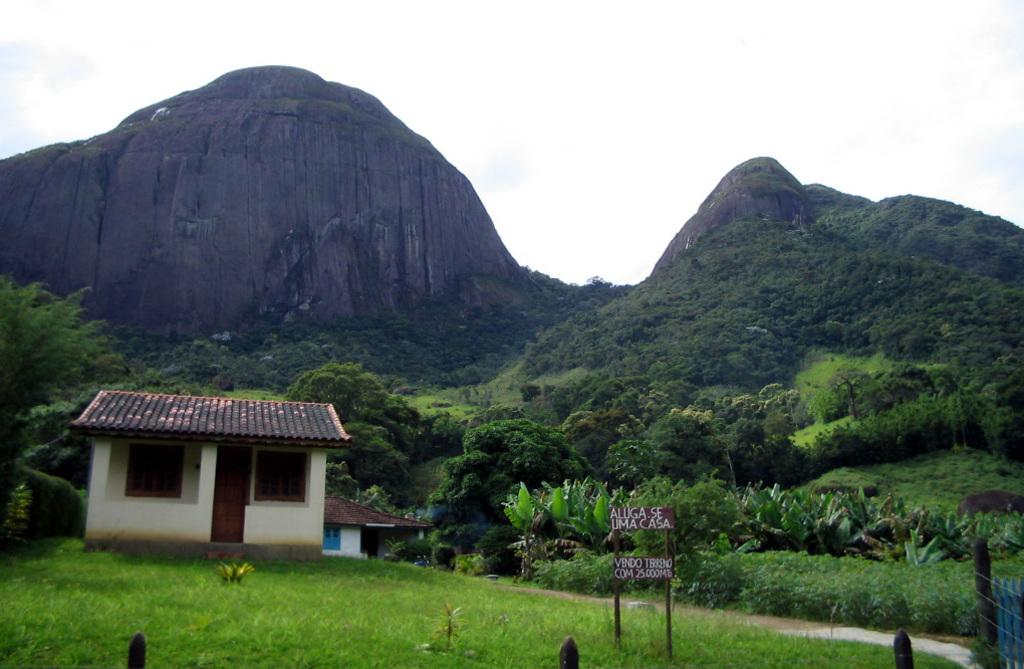What type of surface is in front of the image? There is grass on the surface in front of the image. What type of structures can be seen in the image? There are houses in the image. What are the name boards used for in the image? Name boards are present in the image to indicate names or labels. What type of vegetation is visible in the image besides grass? There are plants and trees visible in the image. What type of geographical feature is visible in the background of the image? Rocky mountains are in the background of the image. What type of slope is visible in the image? There is no slope visible in the image; it features grass, houses, name boards, plants, trees, and rocky mountains. What caused the rocky mountains to form in the image? The image does not provide information about the cause of the rocky mountains' formation; it only shows their presence in the background. 